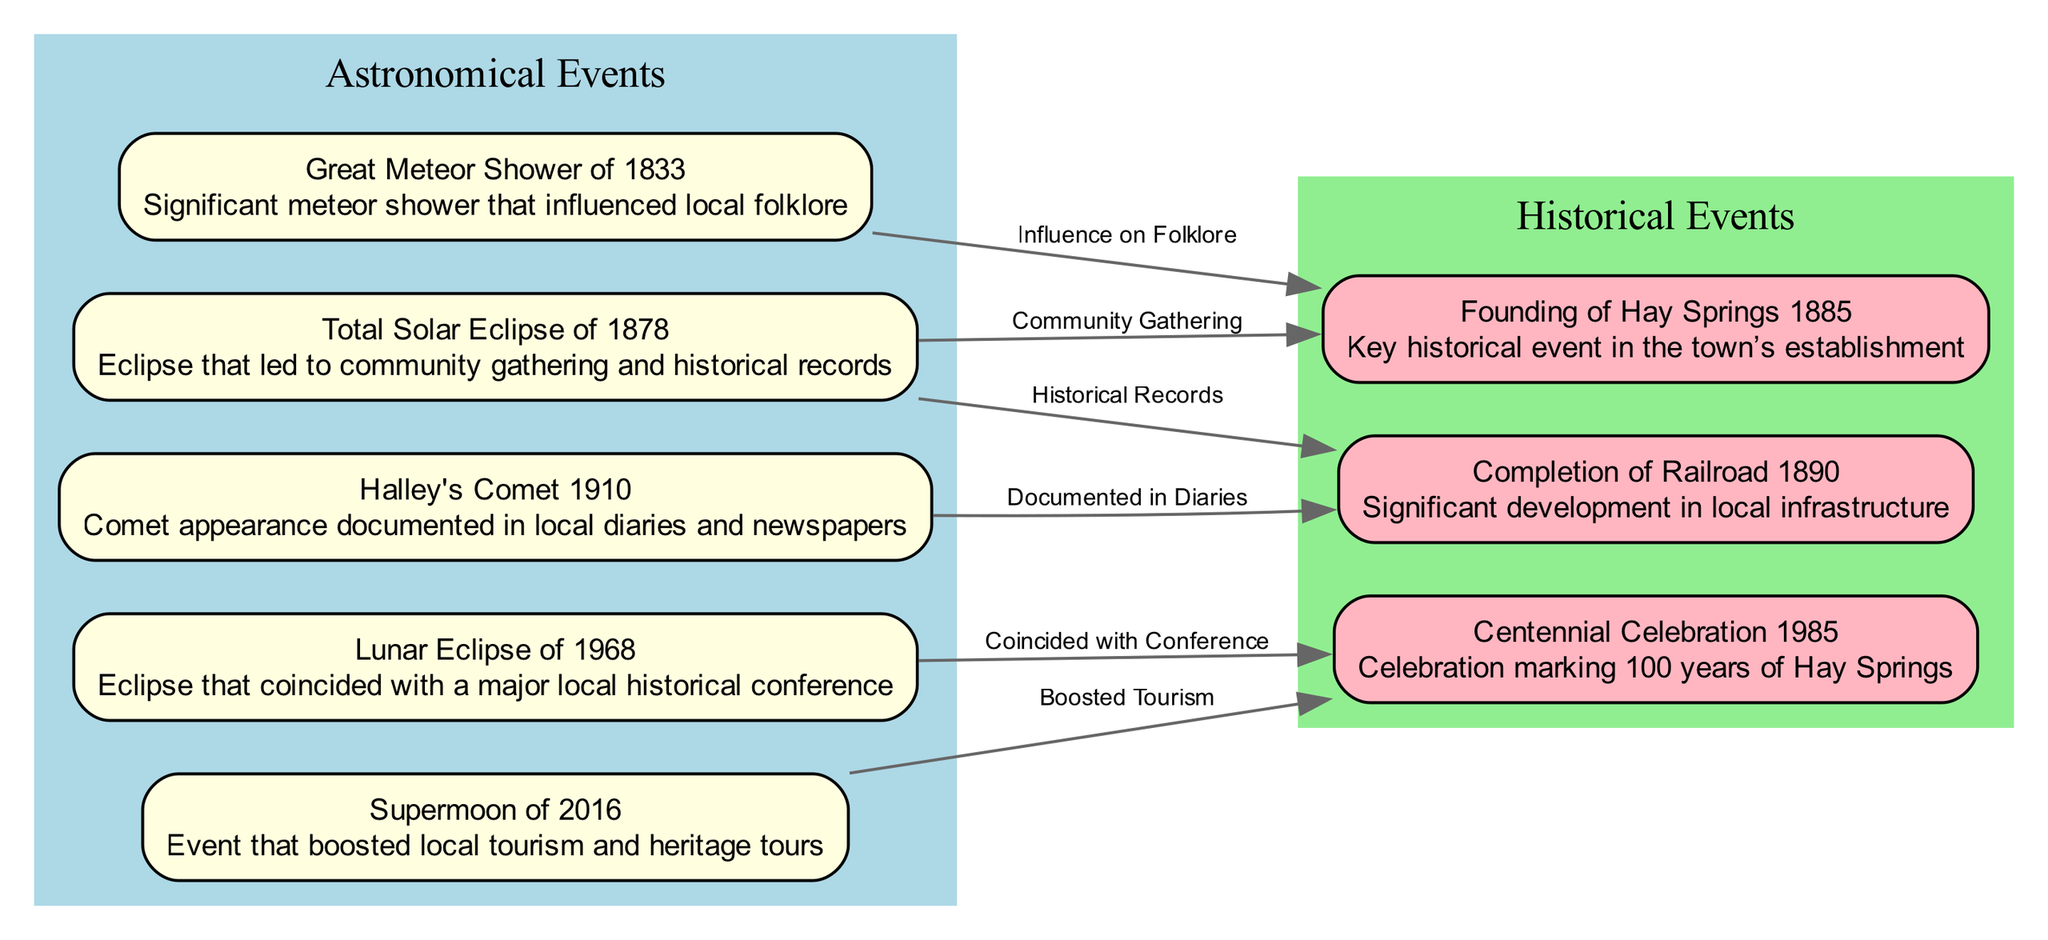What is the first astronomical event listed in the diagram? The diagram starts with a node labeled "Great Meteor Shower of 1833", which is the first event in the list of astronomical events.
Answer: Great Meteor Shower of 1833 How many historical events are depicted in the diagram? There are three nodes labeled as historical events in the diagram, specifically "Founding of Hay Springs 1885", "Completion of Railroad 1890", and "Centennial Celebration 1985".
Answer: 3 What is the influence of the Total Solar Eclipse of 1878 on the Founding of Hay Springs? The "Total Solar Eclipse of 1878" is linked to the "Founding of Hay Springs 1885" with the label "Community Gathering", indicating that this eclipse inspired local community engagement during the time of the town's establishment.
Answer: Community Gathering Which astronomical event is associated with the Centennial Celebration of 1985? The "Lunar Eclipse of 1968" is connected to the "Centennial Celebration 1985", and the edge label states that it coincided with the conference held at that time, indicating its significance in local history.
Answer: Coincided with Conference What is the connection between Halley's Comet 1910 and the Completion of Railroad 1890? The connection is represented by an edge from "Halley's Comet 1910" to "Completion of Railroad 1890", with the label "Documented in Diaries", showing that the appearance of Halley's Comet was recorded in local diaries around the time the railroad was completed.
Answer: Documented in Diaries What was boosted by the Supermoon of 2016? The Supermoon of 2016 is associated with the "Centennial Celebration 1985" through the label "Boosted Tourism", indicating that this astronomical event significantly increased local tourism and heritage tours during that time.
Answer: Boosted Tourism 